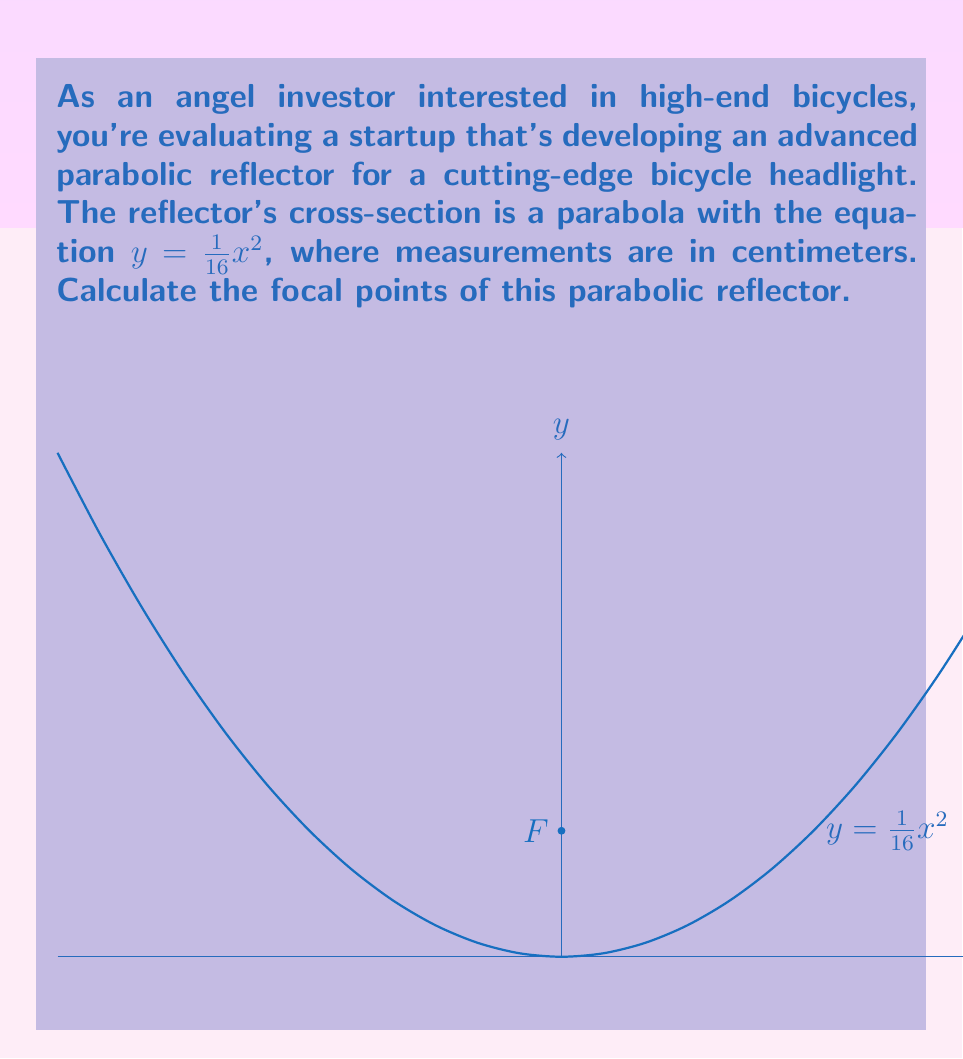Provide a solution to this math problem. Let's approach this step-by-step:

1) The general form of a parabola with a vertical axis of symmetry is:
   $y = a(x-h)^2 + k$
   where $(h,k)$ is the vertex and $a$ determines the direction and width of the parabola.

2) Our equation is $y = \frac{1}{16}x^2$, which is already in the form $y = ax^2$.
   This means the vertex is at $(0,0)$ and $a = \frac{1}{16}$.

3) For a parabola with equation $y = ax^2$, the focal length (distance from vertex to focus) is given by the formula:
   $f = \frac{1}{4a}$

4) Substituting our value of $a$:
   $f = \frac{1}{4(\frac{1}{16})} = \frac{1}{\frac{1}{4}} = 4$

5) Since the parabola opens upward and the vertex is at $(0,0)$, the focus will be 4 units above the vertex on the y-axis.

6) Therefore, the coordinates of the focus are $(0,4)$.

In the context of the bicycle headlight, this means the light source should be placed 4 cm above the vertex of the parabolic reflector for optimal light focusing.
Answer: $(0,4)$ 